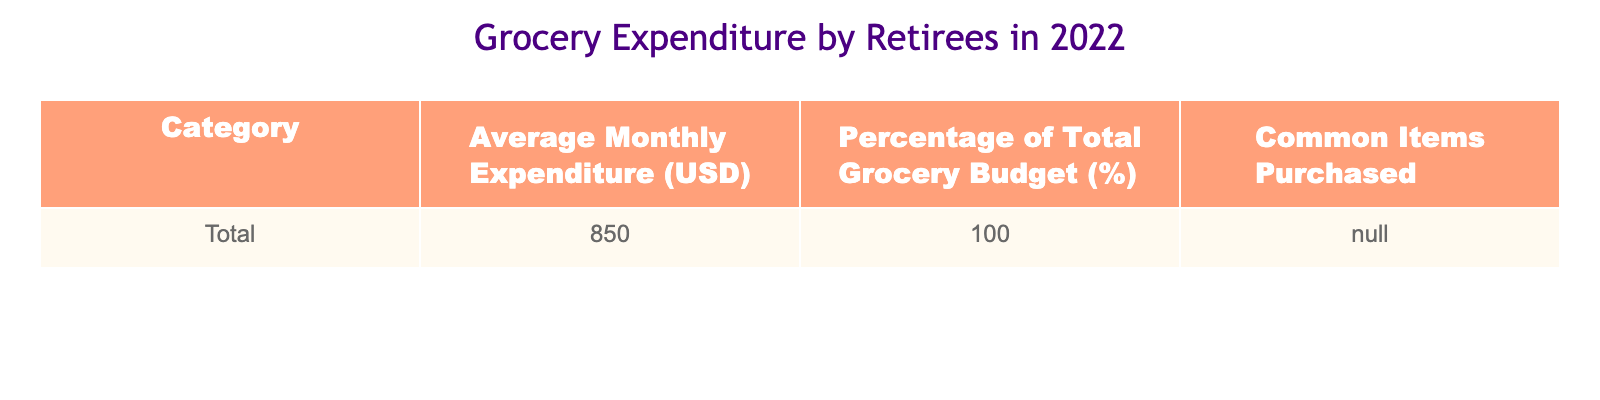What is the average monthly expenditure of retirees on groceries in 2022? The table states that the "Average Monthly Expenditure (USD)" for retirees is 850. Therefore, the average monthly expenditure is directly taken from this value.
Answer: 850 What percentage of the total grocery budget is represented by the average monthly expenditure? The table indicates that the "Percentage of Total Grocery Budget (%)" for retirees is 100. Thus, this means that the average monthly expenditure accounts for the entire grocery budget, which is 100%.
Answer: 100 Is the average monthly expenditure of retirees on groceries greater than 800 USD? The average monthly expenditure listed in the table is 850 USD, which is greater than 800 USD. Therefore, the answer is "yes" based on this comparison.
Answer: Yes What is the total grocery expenditure of retirees if they maintain the average expenditure for an entire year? The average monthly expenditure is 850. To find the total for a year, we multiply this by 12 months: 850 * 12 = 10,200. Therefore, the total grocery expenditure over a year is found through this multiplication.
Answer: 10,200 If retirees were to decrease their grocery budget by 10% next year, what would that average monthly expenditure be? Starting from the average monthly expenditure of 850, calculating a 10% decrease involves finding 10% of 850 (which is 85) and subtracting that from 850. So, 850 - 85 = 765. Thus, the new average would be calculated as 765 after the reduction.
Answer: 765 In terms of grocery expenditure, is it true that retirees are expected to spend more than $900 on average in 2022? The table clearly states that the average monthly expenditure is 850, which is less than 900. Therefore, the statement is false.
Answer: No What is the difference between the average monthly expenditure and the total percentage of budget? The average monthly expenditure is 850 and the total percentage of budget is 100. Since the two values are in different units, the logical operation is not directly applicable; however, in a metaphorical sense, you can think of the values as being separate categories, thereby reaffirming that they don’t have a numerical difference to be calculated from different contexts.
Answer: N/A If the average expenditure were to increase by 5%, what would the new average monthly expenditure be? To calculate a 5% increase on the average of 850, we first find 5% of 850, which is 42.5, then add that to 850 together: 850 + 42.5 = 892.5. Thus, after the increase, the new average monthly expenditure would be 892.5.
Answer: 892.5 